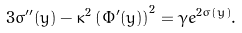<formula> <loc_0><loc_0><loc_500><loc_500>3 \sigma ^ { \prime \prime } ( y ) - \kappa ^ { 2 } \left ( \Phi ^ { \prime } ( y ) \right ) ^ { 2 } = \gamma e ^ { 2 \sigma ( y ) } .</formula> 